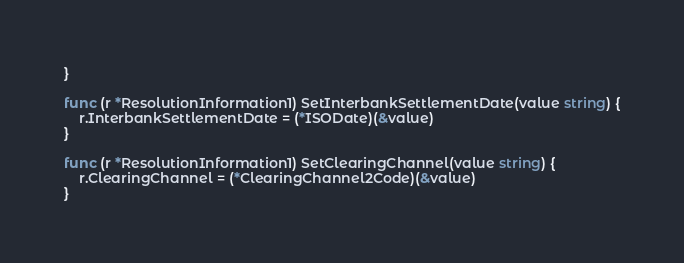Convert code to text. <code><loc_0><loc_0><loc_500><loc_500><_Go_>}

func (r *ResolutionInformation1) SetInterbankSettlementDate(value string) {
	r.InterbankSettlementDate = (*ISODate)(&value)
}

func (r *ResolutionInformation1) SetClearingChannel(value string) {
	r.ClearingChannel = (*ClearingChannel2Code)(&value)
}
</code> 